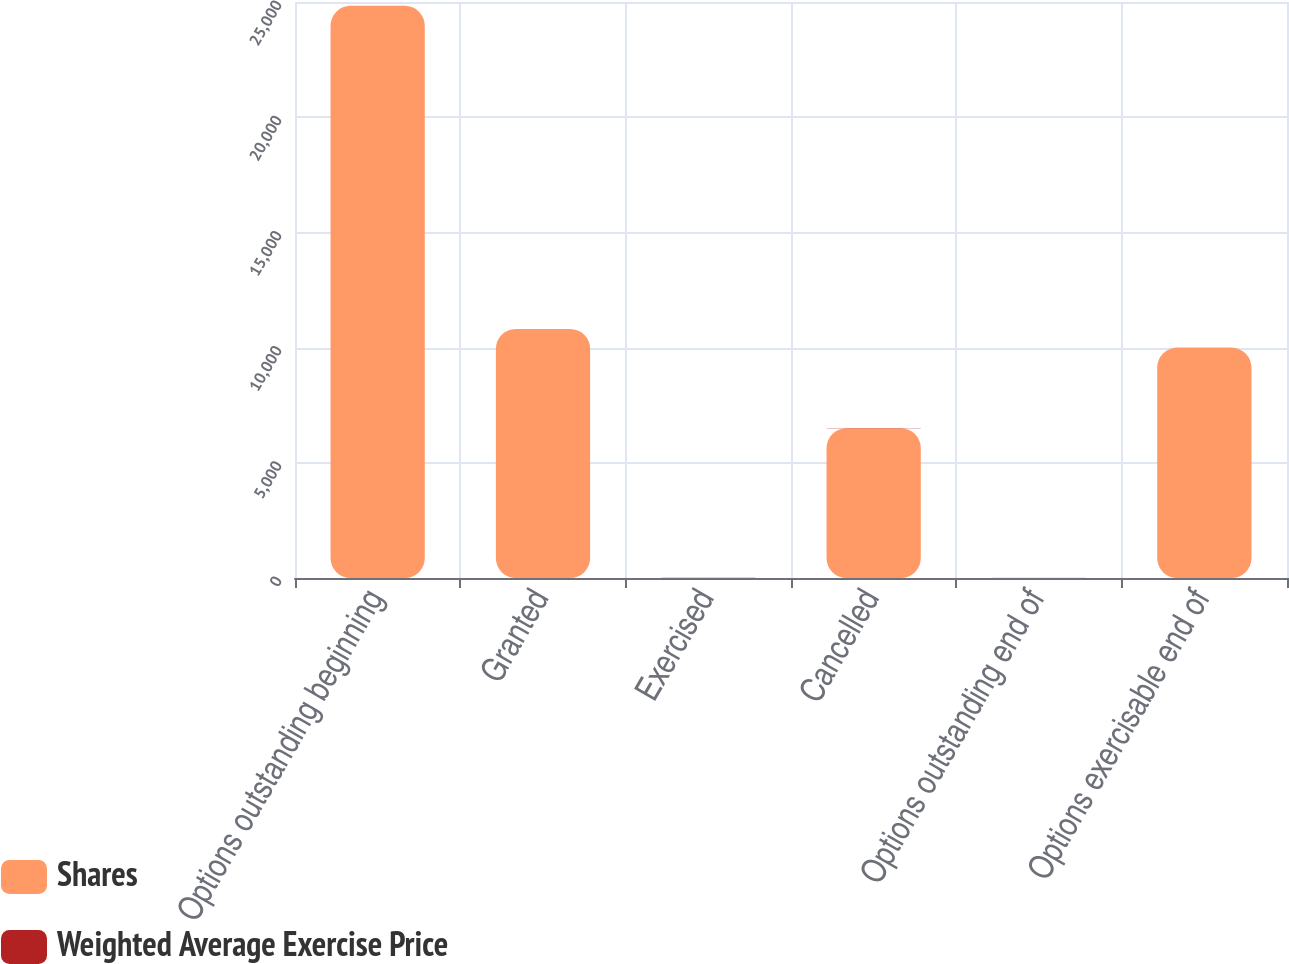Convert chart. <chart><loc_0><loc_0><loc_500><loc_500><stacked_bar_chart><ecel><fcel>Options outstanding beginning<fcel>Granted<fcel>Exercised<fcel>Cancelled<fcel>Options outstanding end of<fcel>Options exercisable end of<nl><fcel>Shares<fcel>24835<fcel>10810<fcel>17<fcel>6501<fcel>7.8<fcel>9999<nl><fcel>Weighted Average Exercise Price<fcel>6.57<fcel>1.36<fcel>1.11<fcel>7.4<fcel>4.47<fcel>7.8<nl></chart> 